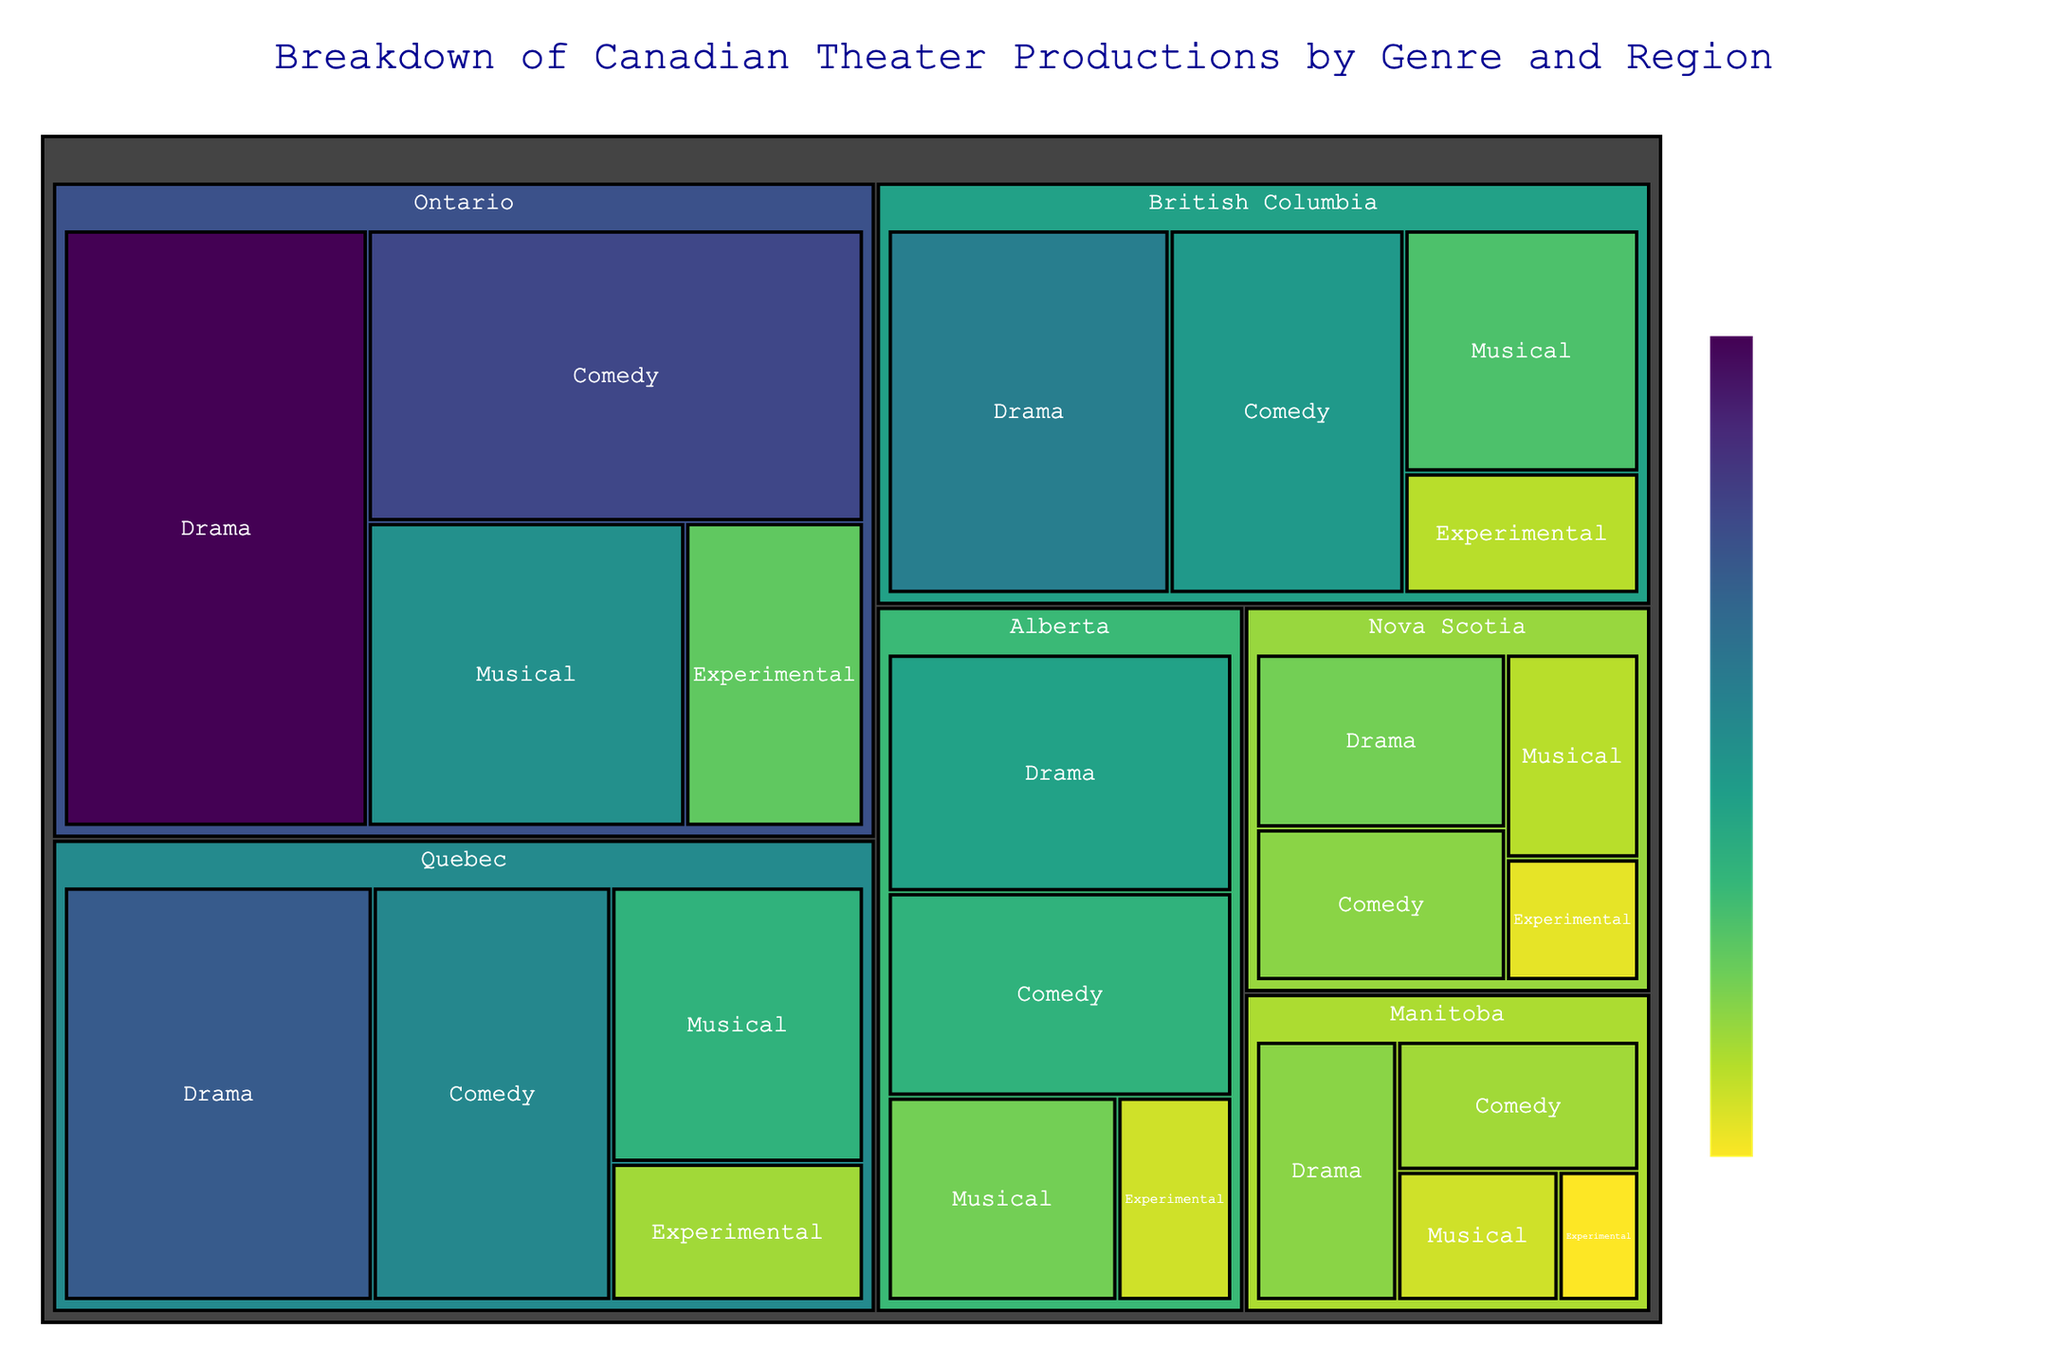What's the title of the treemap? The title is usually shown at the top of the figure. In this case, it is "Breakdown of Canadian Theater Productions by Genre and Region"
Answer: Breakdown of Canadian Theater Productions by Genre and Region Which region has the highest number of drama productions? By looking at the size of the sections labeled "Drama" in each region, Ontario has the largest section, indicating the highest number of drama productions.
Answer: Ontario Which genre has the smallest number of productions in Quebec? The smallest section within the Quebec regions indicates the genre with the fewest productions, which is "Experimental"
Answer: Experimental How many total comedy productions are there across all regions? Sum the number of comedy productions from all regions: 120 (Ontario) + 85 (Quebec) + 75 (British Columbia) + 60 (Alberta) + 35 (Nova Scotia) + 30 (Manitoba) = 405
Answer: 405 In which region is the gap between drama and experimental productions the widest? Calculate the difference between drama and experimental productions for each region:
Ontario: 150 - 45 = 105  
Quebec: 110 - 30 = 80  
British Columbia: 90 - 25 = 65  
Alberta: 70 - 20 = 50  
Nova Scotia: 40 - 15 = 25  
Manitoba: 35 - 10 = 25 
Ontario has the biggest gap.
Answer: Ontario Which region has more musical productions, British Columbia or Quebec, and by how many? Subtract the number of musical productions in British Columbia from Quebec: 60 (Quebec) - 50 (British Columbia) = 10. Hence, Quebec has 10 more musical productions.
Answer: Quebec, 10 What percentage of Alberta's theater productions are drama? Calculate the total productions in Alberta and the drama ratio: 
Total = 70 (Drama) + 60 (Comedy) + 40 (Musical) + 20 (Experimental) = 190  
Drama ratio = (70 / 190) * 100 ≈ 36.84%.
Answer: 36.84% Which genre has the highest total number of productions across all regions? Sum each genre's production numbers: 
Drama: 150 + 110 + 90 + 70 + 40 + 35 = 495  
Comedy: 120 + 85 + 75 + 60 + 35 + 30 = 405  
Musical: 80 + 60 + 50 + 40 + 25 + 20 = 275  
Experimental: 45 + 30 + 25 + 20 + 15 + 10 = 145  
Drama has the highest number.
Answer: Drama Which region has the most diversified theater genre production (most different genres with close production numbers)? Look for the region where the treemap sections are closest in size, most balanced between different genres. Alberta and Nova Scotia stand out relative to others.
Answer: Alberta or Nova Scotia 